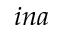<formula> <loc_0><loc_0><loc_500><loc_500>i n a</formula> 